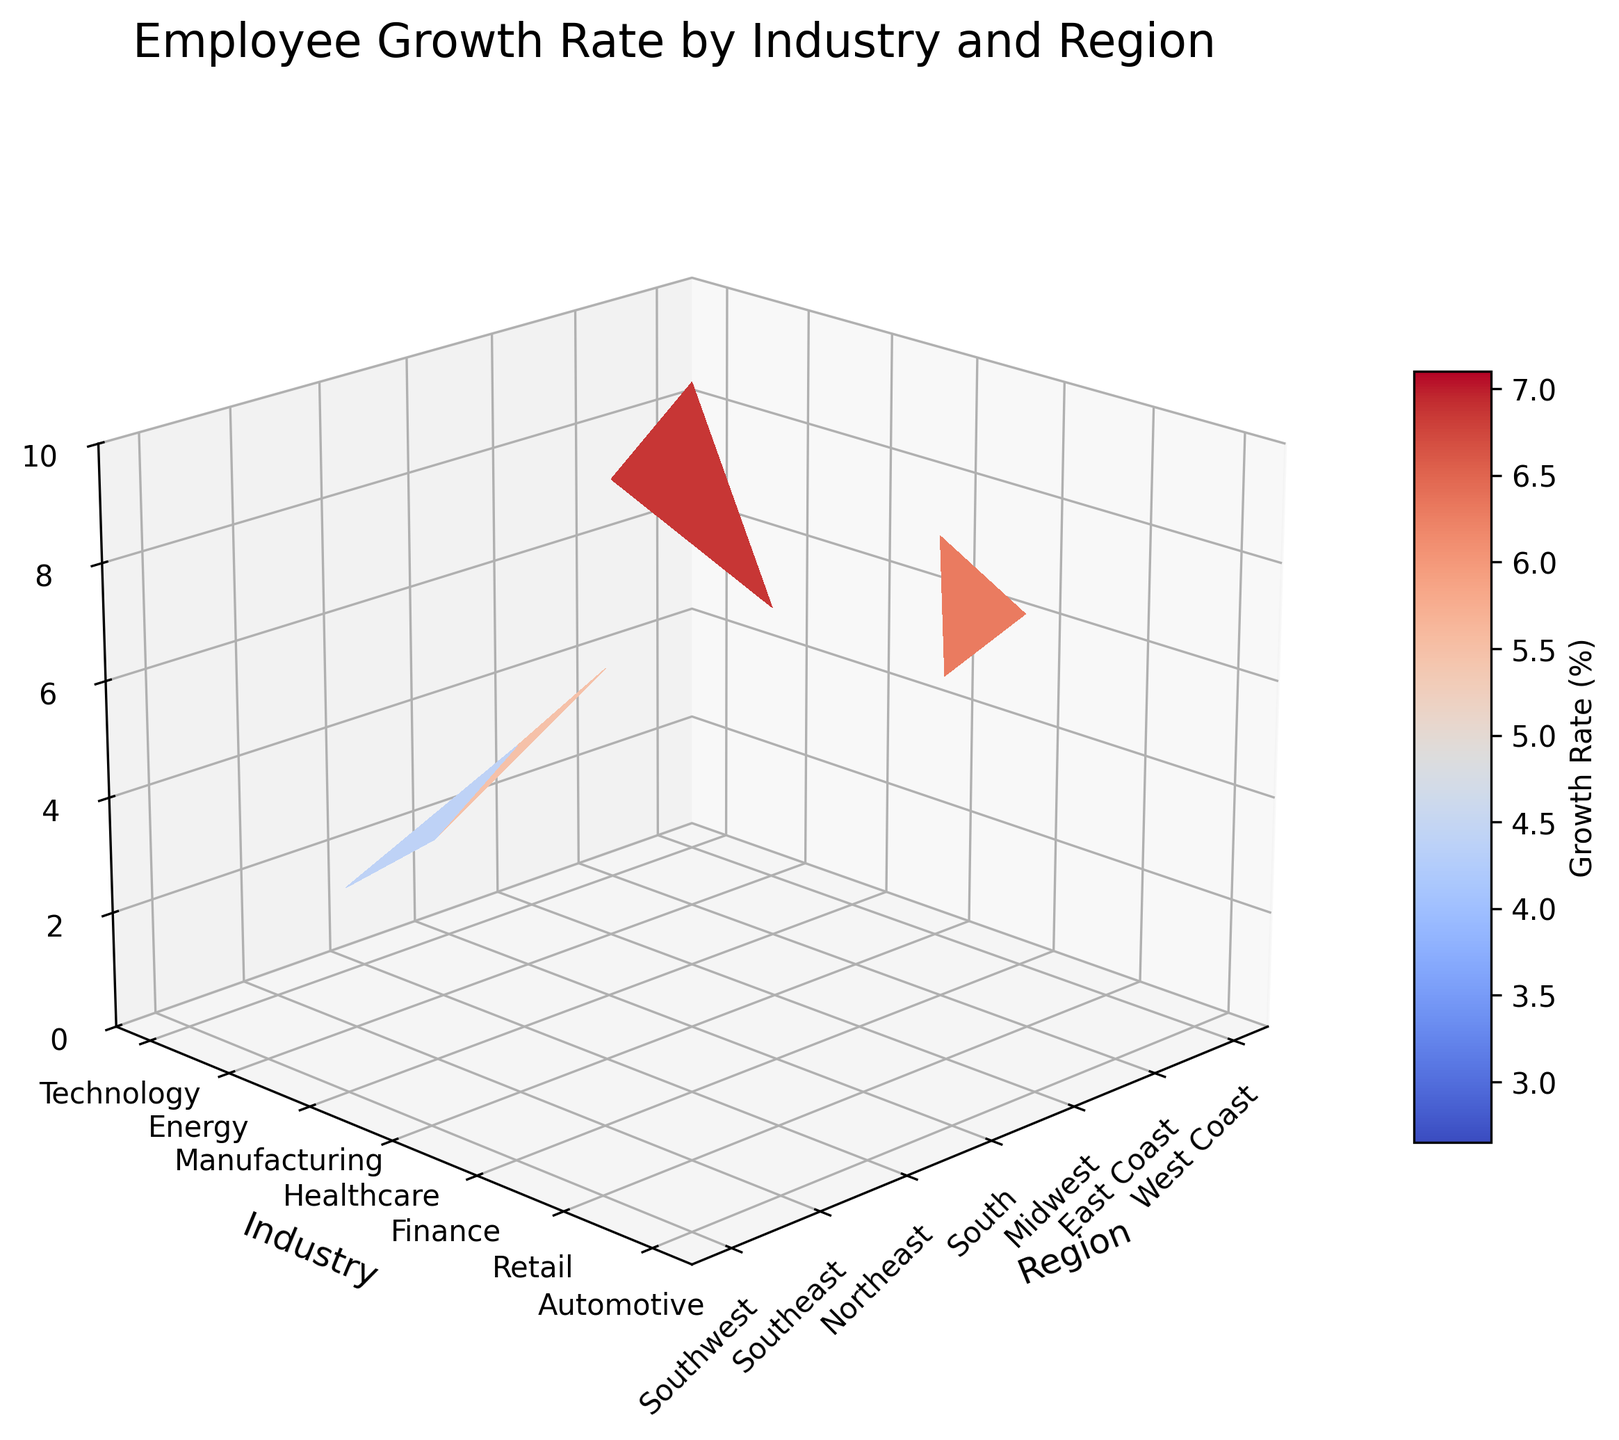what is the primary color of the 3D surface plot? The primary color of the surface plot is determined by the colormap applied, which in this case is 'cm.coolwarm', displaying a gradient between cool and warm colors.
Answer: A mix of cool and warm colors What is the title of the figure? The title is provided at the top of the plot that summarizes the main focus of the data.
Answer: Employee Growth Rate by Industry and Region What does the Z-axis represent? The Z-axis indicates the variable represented on this axis, which can be found next to the axis itself.
Answer: Employee Growth Rate (%) Which region shows the highest employee growth rate for the Technology industry? By locating the Technology industry on the y-axis and finding the highest point along its z-axis for different regions, we determine the region with the highest growth rate.
Answer: West Coast Which industry has the overall lowest employee growth rate in the plot? By examining all the values on the z-axis for different industries, one can find the industry with the lowest minimum growth rate.
Answer: Automotive What's the average employee growth rate for the Healthcare industry across all regions? Locate Healthcare industry on the y-axis, sum up the z-values across all regions and divide by the number of regions (3). (6.7 + 5.9 + 7.1) / 3 = 6.57
Answer: 6.57 Which region shows the smallest growth rate for the Energy industry? By focusing on the Energy industry on the y-axis, find the smallest value on the z-axis for its regions.
Answer: Northeast Is the employee growth rate in Technology uniformly high across all regions? By examining the z-values for Technology across West Coast, East Coast, and Midwest, check if they are comparably high. Technology’s growth rates are 8.5 (West Coast), 7.2 (East Coast), and 5.8 (Midwest), which are not uniform.
Answer: No How does the employee growth rate in the Finance industry on the East Coast compare to that on the West Coast? Look at the z-values for Finance industry in the East Coast and West Coast regions and compare them (5.6 vs. 6.2).
Answer: West Coast is higher What patterns are evident in the employee growth rates across different industries when comparing the Midwest region? By observing the z-values for different industries in the Midwest, notice if there's a trend or specific pattern (Technology: 5.8, Manufacturing: 4.2, Finance: 4.3, Automotive: 2.8). Different industries show varying growth rates; Manufacturing and Finance have similar values, while Technology is higher, and Automotive is lower.
Answer: Varied growth rates, Technology highest, Automotive lowest 